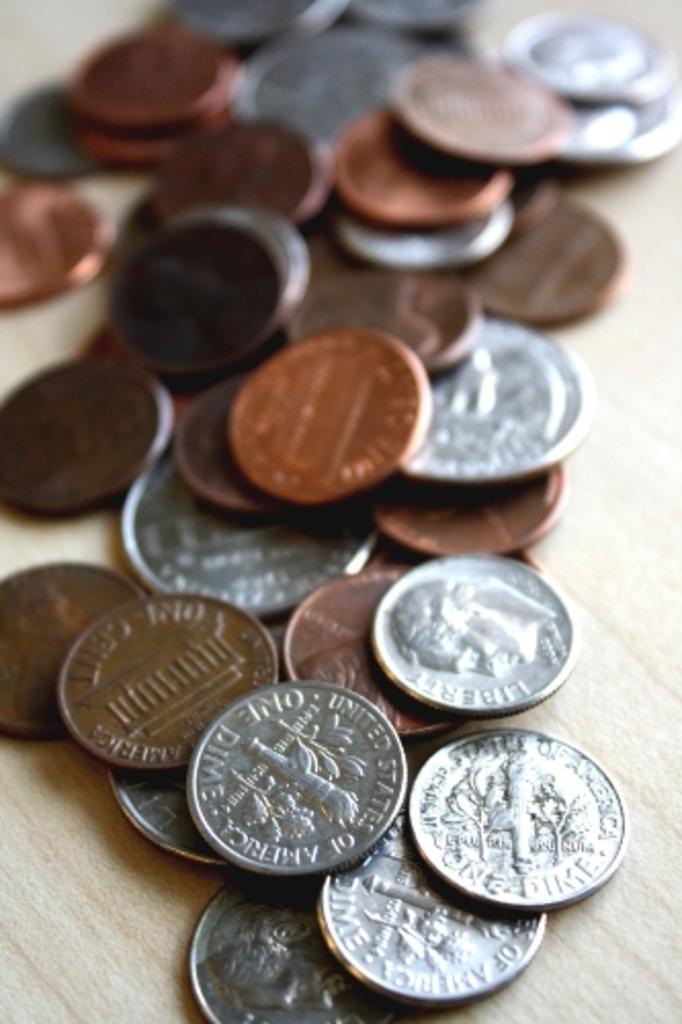What is written on the dime?
Offer a very short reply. United states of america one dime. What words can you see on the darkest coin to the front?
Your answer should be compact. One cent. 